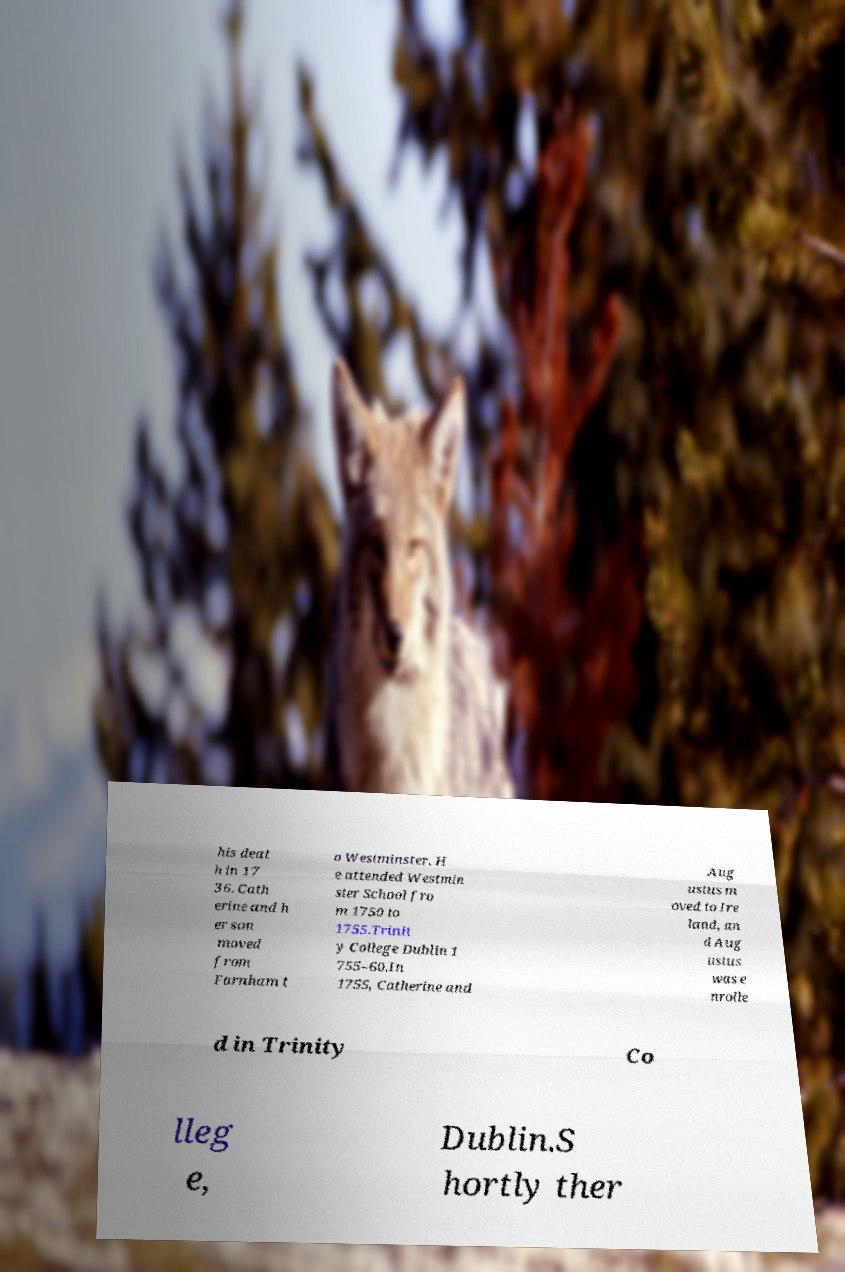Please read and relay the text visible in this image. What does it say? his deat h in 17 36. Cath erine and h er son moved from Farnham t o Westminster. H e attended Westmin ster School fro m 1750 to 1755.Trinit y College Dublin 1 755–60.In 1755, Catherine and Aug ustus m oved to Ire land, an d Aug ustus was e nrolle d in Trinity Co lleg e, Dublin.S hortly ther 